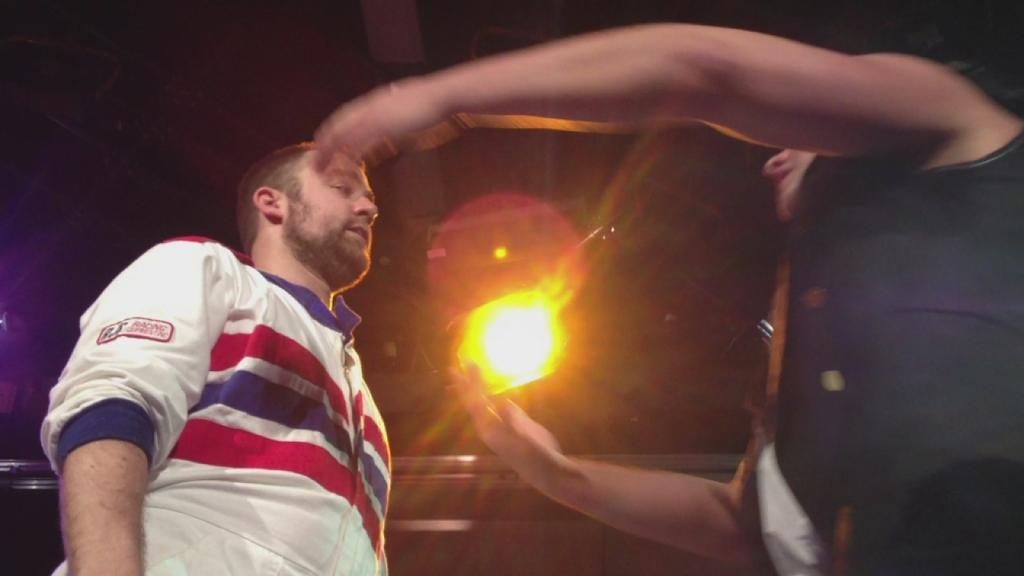Where was the image taken? The image was taken outdoors. What can be seen in the middle of the image? There is a light in the middle of the image. How many people are present in the image? There are two people in the image, one on the right side and another on the left side. What arithmetic problem is the girl solving in the image? There is no girl present in the image, and therefore no arithmetic problem can be observed. How many bikes are visible in the image? There are no bikes visible in the image. 